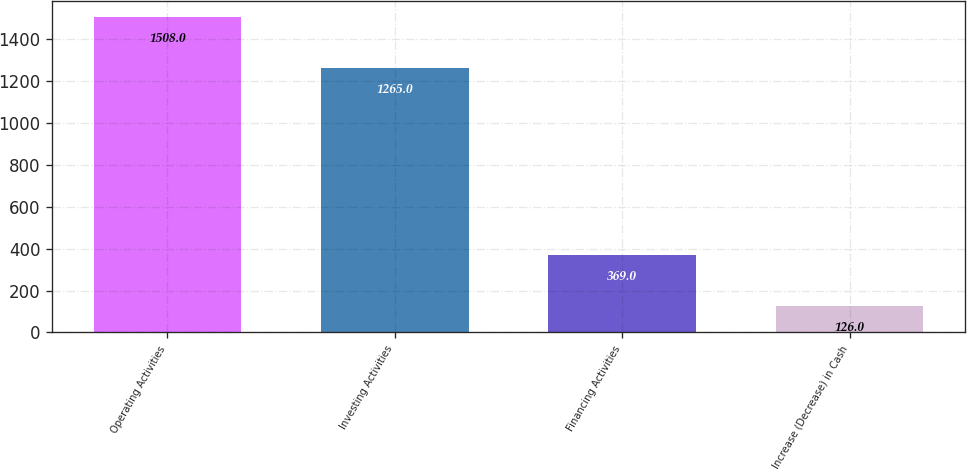Convert chart to OTSL. <chart><loc_0><loc_0><loc_500><loc_500><bar_chart><fcel>Operating Activities<fcel>Investing Activities<fcel>Financing Activities<fcel>Increase (Decrease) in Cash<nl><fcel>1508<fcel>1265<fcel>369<fcel>126<nl></chart> 